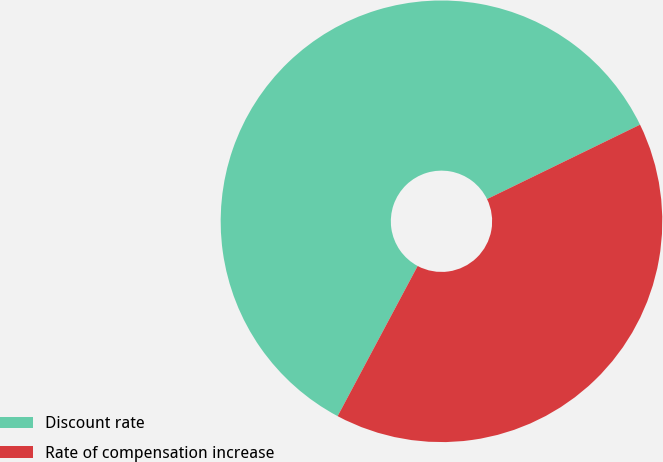Convert chart. <chart><loc_0><loc_0><loc_500><loc_500><pie_chart><fcel>Discount rate<fcel>Rate of compensation increase<nl><fcel>60.0%<fcel>40.0%<nl></chart> 